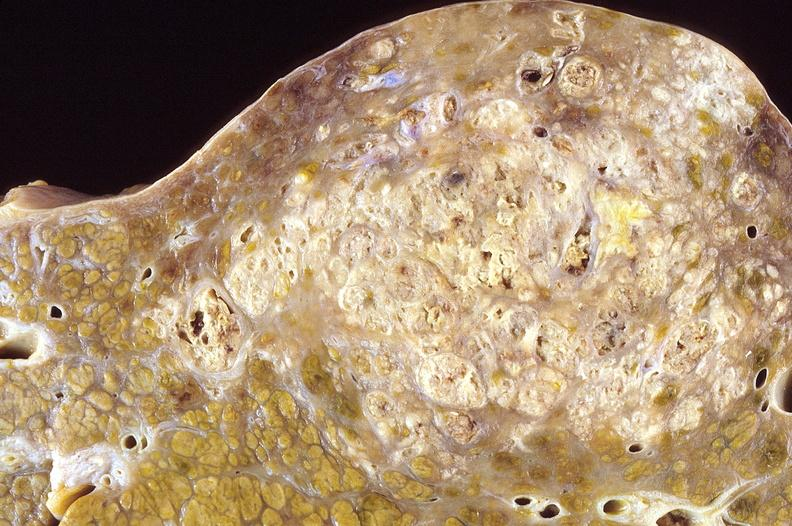does this image show hepatocellular carcinoma, hepatitis c positive?
Answer the question using a single word or phrase. Yes 